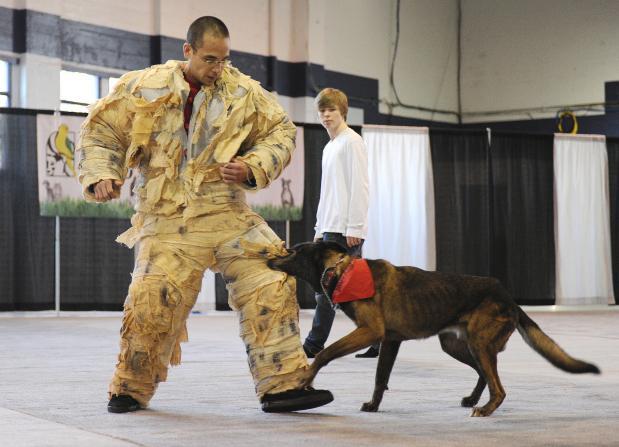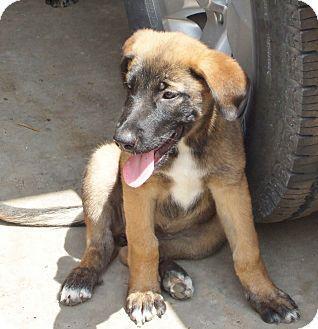The first image is the image on the left, the second image is the image on the right. Given the left and right images, does the statement "An image shows a person at the left, interacting with one big dog." hold true? Answer yes or no. Yes. The first image is the image on the left, the second image is the image on the right. Given the left and right images, does the statement "The left image contains one person standing to the left of a dog." hold true? Answer yes or no. Yes. 